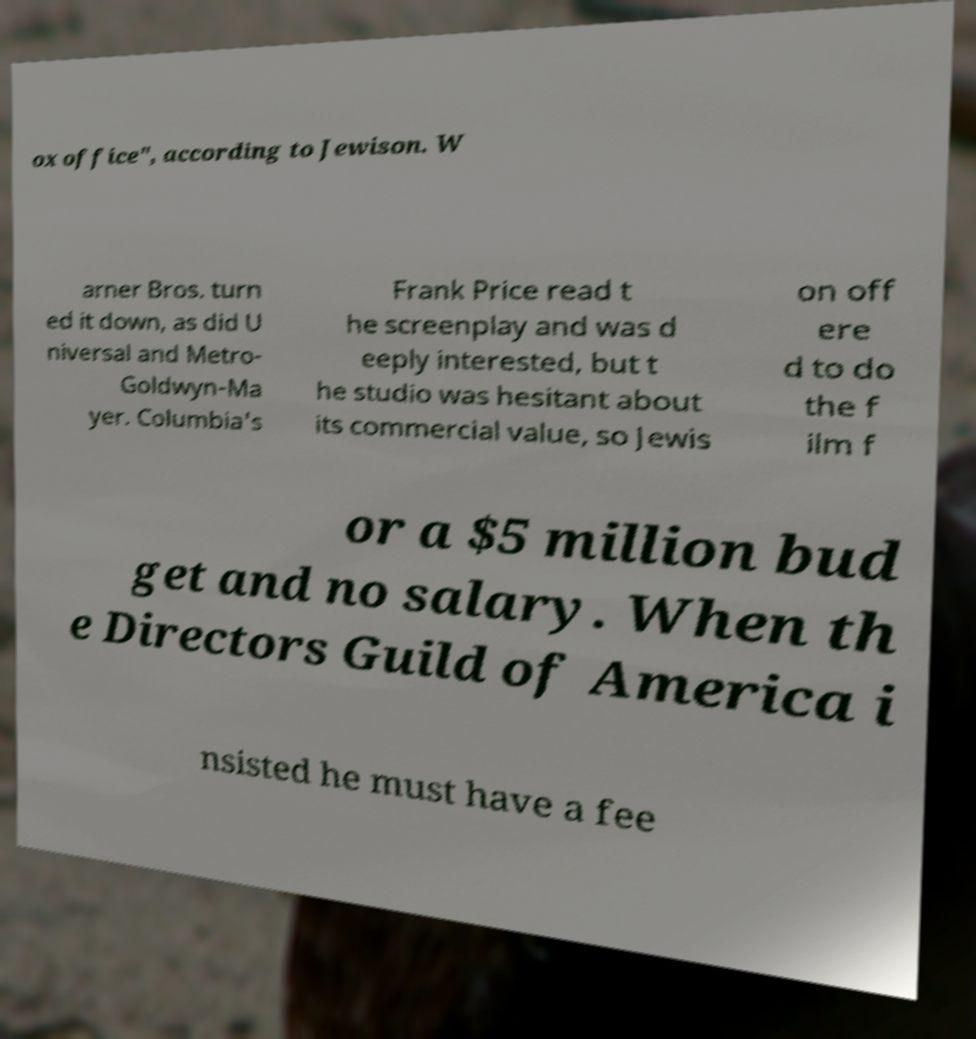For documentation purposes, I need the text within this image transcribed. Could you provide that? ox office", according to Jewison. W arner Bros. turn ed it down, as did U niversal and Metro- Goldwyn-Ma yer. Columbia's Frank Price read t he screenplay and was d eeply interested, but t he studio was hesitant about its commercial value, so Jewis on off ere d to do the f ilm f or a $5 million bud get and no salary. When th e Directors Guild of America i nsisted he must have a fee 